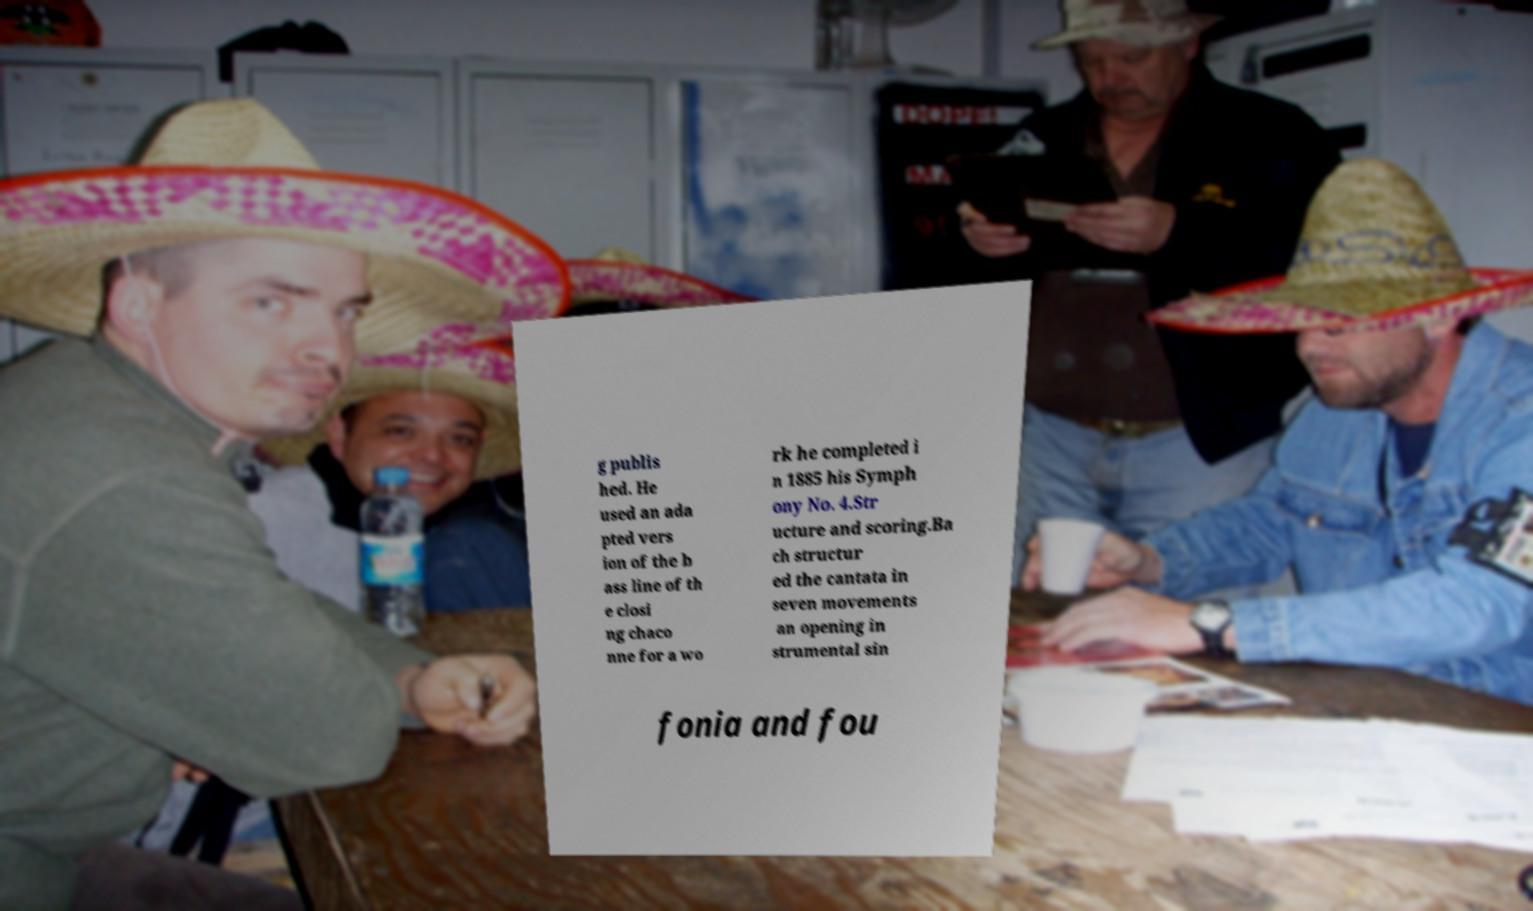Please identify and transcribe the text found in this image. g publis hed. He used an ada pted vers ion of the b ass line of th e closi ng chaco nne for a wo rk he completed i n 1885 his Symph ony No. 4.Str ucture and scoring.Ba ch structur ed the cantata in seven movements an opening in strumental sin fonia and fou 